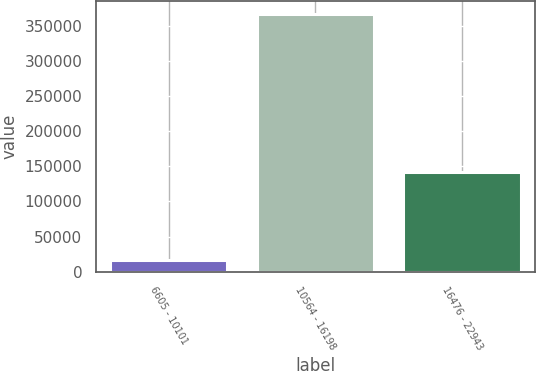Convert chart. <chart><loc_0><loc_0><loc_500><loc_500><bar_chart><fcel>6605 - 10101<fcel>10564 - 16198<fcel>16476 - 22943<nl><fcel>15901<fcel>367024<fcel>142169<nl></chart> 